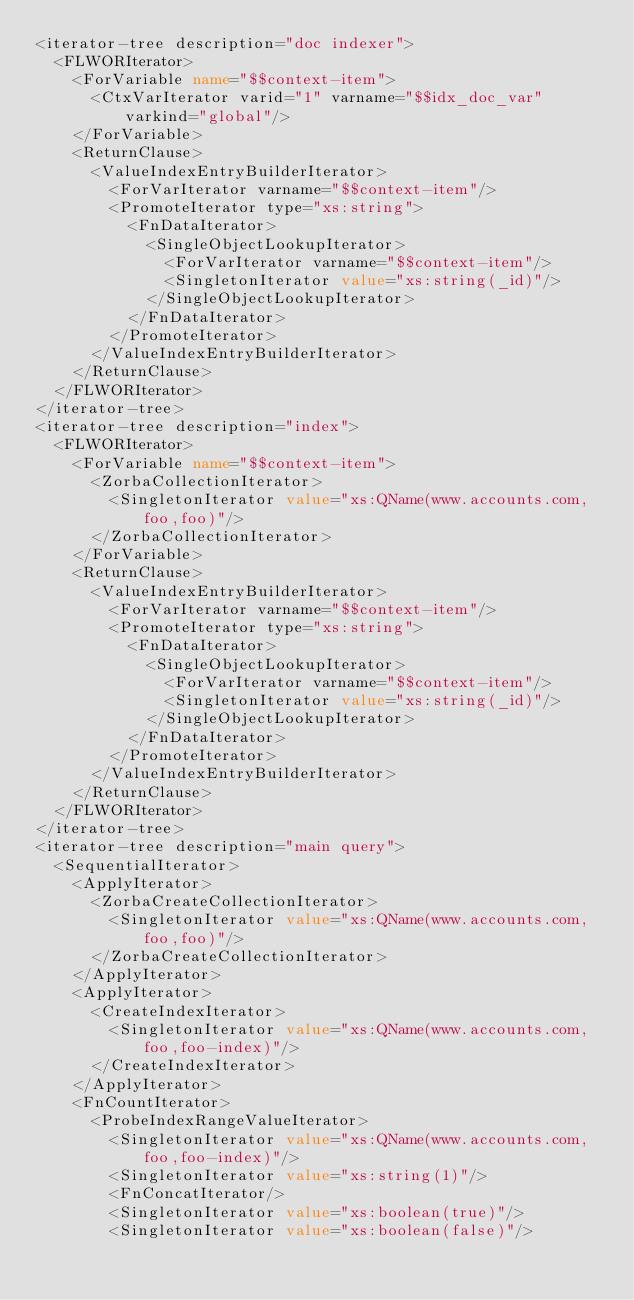Convert code to text. <code><loc_0><loc_0><loc_500><loc_500><_XML_><iterator-tree description="doc indexer">
  <FLWORIterator>
    <ForVariable name="$$context-item">
      <CtxVarIterator varid="1" varname="$$idx_doc_var" varkind="global"/>
    </ForVariable>
    <ReturnClause>
      <ValueIndexEntryBuilderIterator>
        <ForVarIterator varname="$$context-item"/>
        <PromoteIterator type="xs:string">
          <FnDataIterator>
            <SingleObjectLookupIterator>
              <ForVarIterator varname="$$context-item"/>
              <SingletonIterator value="xs:string(_id)"/>
            </SingleObjectLookupIterator>
          </FnDataIterator>
        </PromoteIterator>
      </ValueIndexEntryBuilderIterator>
    </ReturnClause>
  </FLWORIterator>
</iterator-tree>
<iterator-tree description="index">
  <FLWORIterator>
    <ForVariable name="$$context-item">
      <ZorbaCollectionIterator>
        <SingletonIterator value="xs:QName(www.accounts.com,foo,foo)"/>
      </ZorbaCollectionIterator>
    </ForVariable>
    <ReturnClause>
      <ValueIndexEntryBuilderIterator>
        <ForVarIterator varname="$$context-item"/>
        <PromoteIterator type="xs:string">
          <FnDataIterator>
            <SingleObjectLookupIterator>
              <ForVarIterator varname="$$context-item"/>
              <SingletonIterator value="xs:string(_id)"/>
            </SingleObjectLookupIterator>
          </FnDataIterator>
        </PromoteIterator>
      </ValueIndexEntryBuilderIterator>
    </ReturnClause>
  </FLWORIterator>
</iterator-tree>
<iterator-tree description="main query">
  <SequentialIterator>
    <ApplyIterator>
      <ZorbaCreateCollectionIterator>
        <SingletonIterator value="xs:QName(www.accounts.com,foo,foo)"/>
      </ZorbaCreateCollectionIterator>
    </ApplyIterator>
    <ApplyIterator>
      <CreateIndexIterator>
        <SingletonIterator value="xs:QName(www.accounts.com,foo,foo-index)"/>
      </CreateIndexIterator>
    </ApplyIterator>
    <FnCountIterator>
      <ProbeIndexRangeValueIterator>
        <SingletonIterator value="xs:QName(www.accounts.com,foo,foo-index)"/>
        <SingletonIterator value="xs:string(1)"/>
        <FnConcatIterator/>
        <SingletonIterator value="xs:boolean(true)"/>
        <SingletonIterator value="xs:boolean(false)"/></code> 